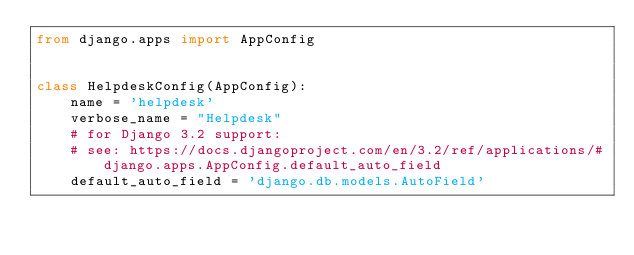Convert code to text. <code><loc_0><loc_0><loc_500><loc_500><_Python_>from django.apps import AppConfig


class HelpdeskConfig(AppConfig):
    name = 'helpdesk'
    verbose_name = "Helpdesk"
    # for Django 3.2 support:
    # see: https://docs.djangoproject.com/en/3.2/ref/applications/#django.apps.AppConfig.default_auto_field
    default_auto_field = 'django.db.models.AutoField'
</code> 